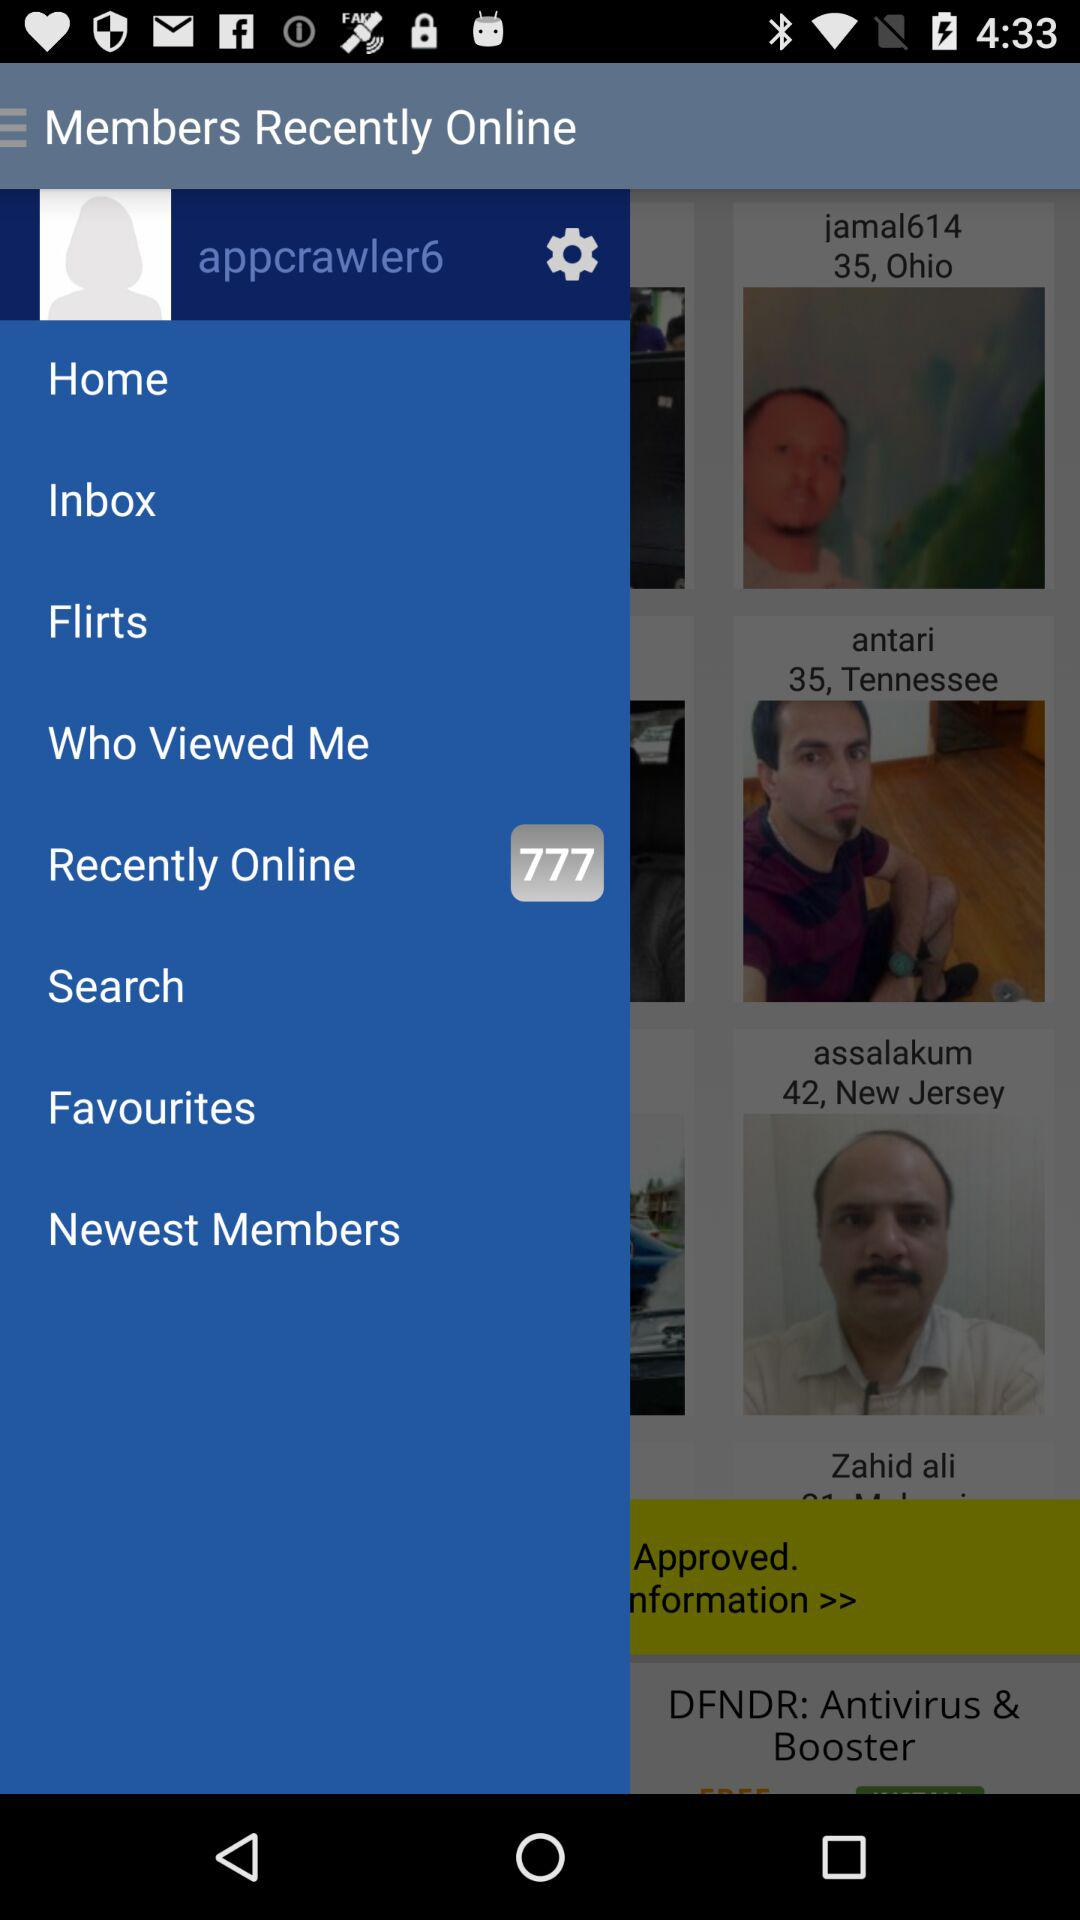What's the username? The username is "appcrawler6". 